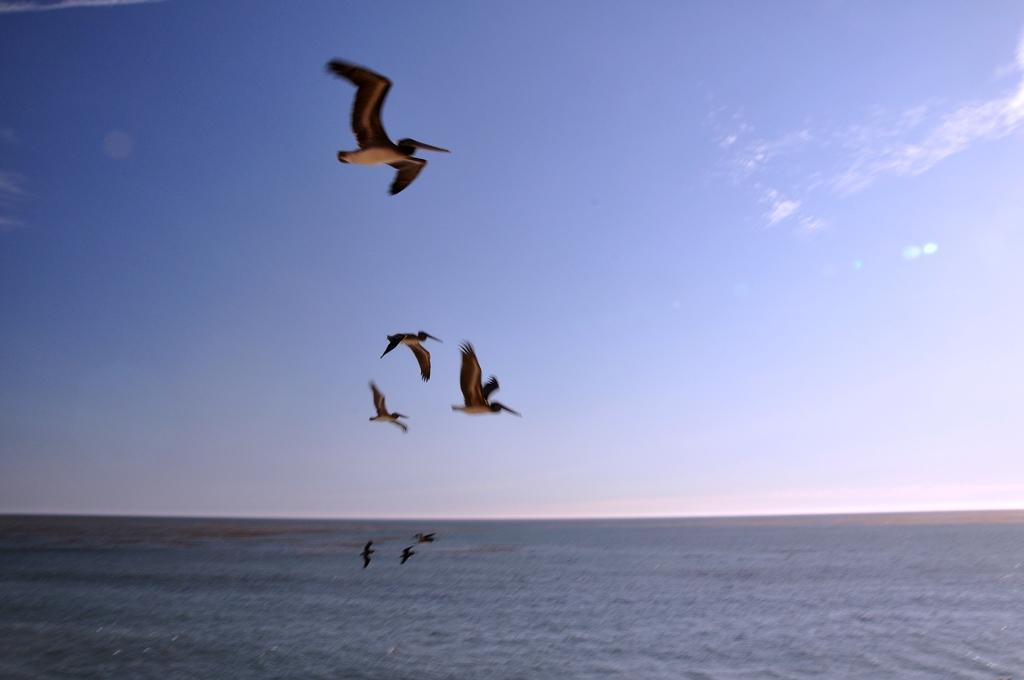What is happening in the sky in the image? There are birds flying in the air in the image. What can be seen below the birds in the image? There is water visible in the image. What else is visible in the image besides the birds and water? The sky is visible in the image. How do the birds use the water in the image? The image does not show the birds using the water; they are simply flying above it. What type of love can be seen between the birds in the image? There is no indication of love between the birds in the image; they are simply flying. 